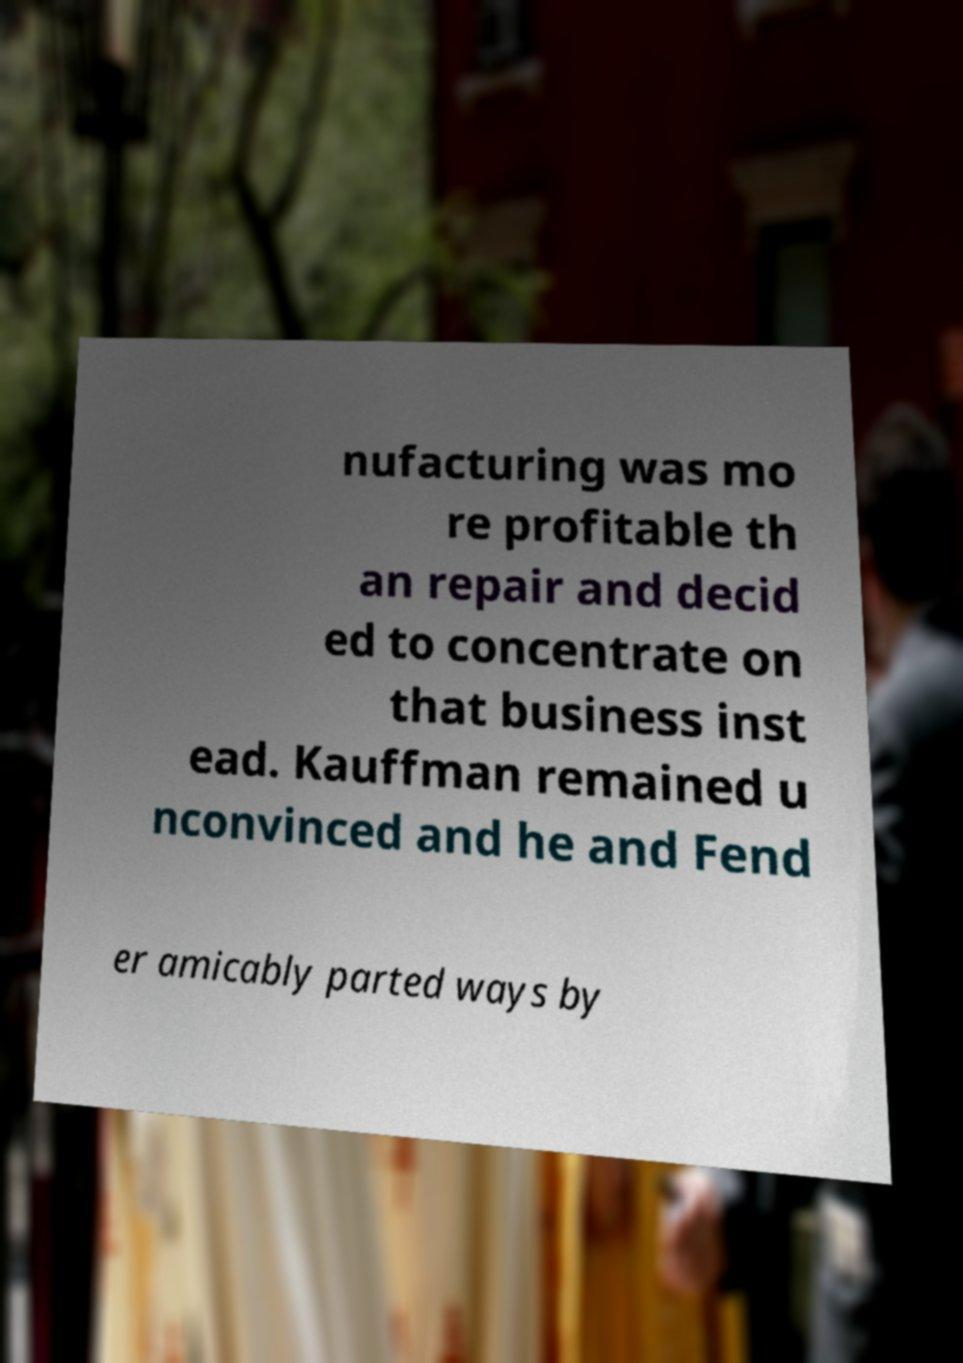Could you extract and type out the text from this image? nufacturing was mo re profitable th an repair and decid ed to concentrate on that business inst ead. Kauffman remained u nconvinced and he and Fend er amicably parted ways by 